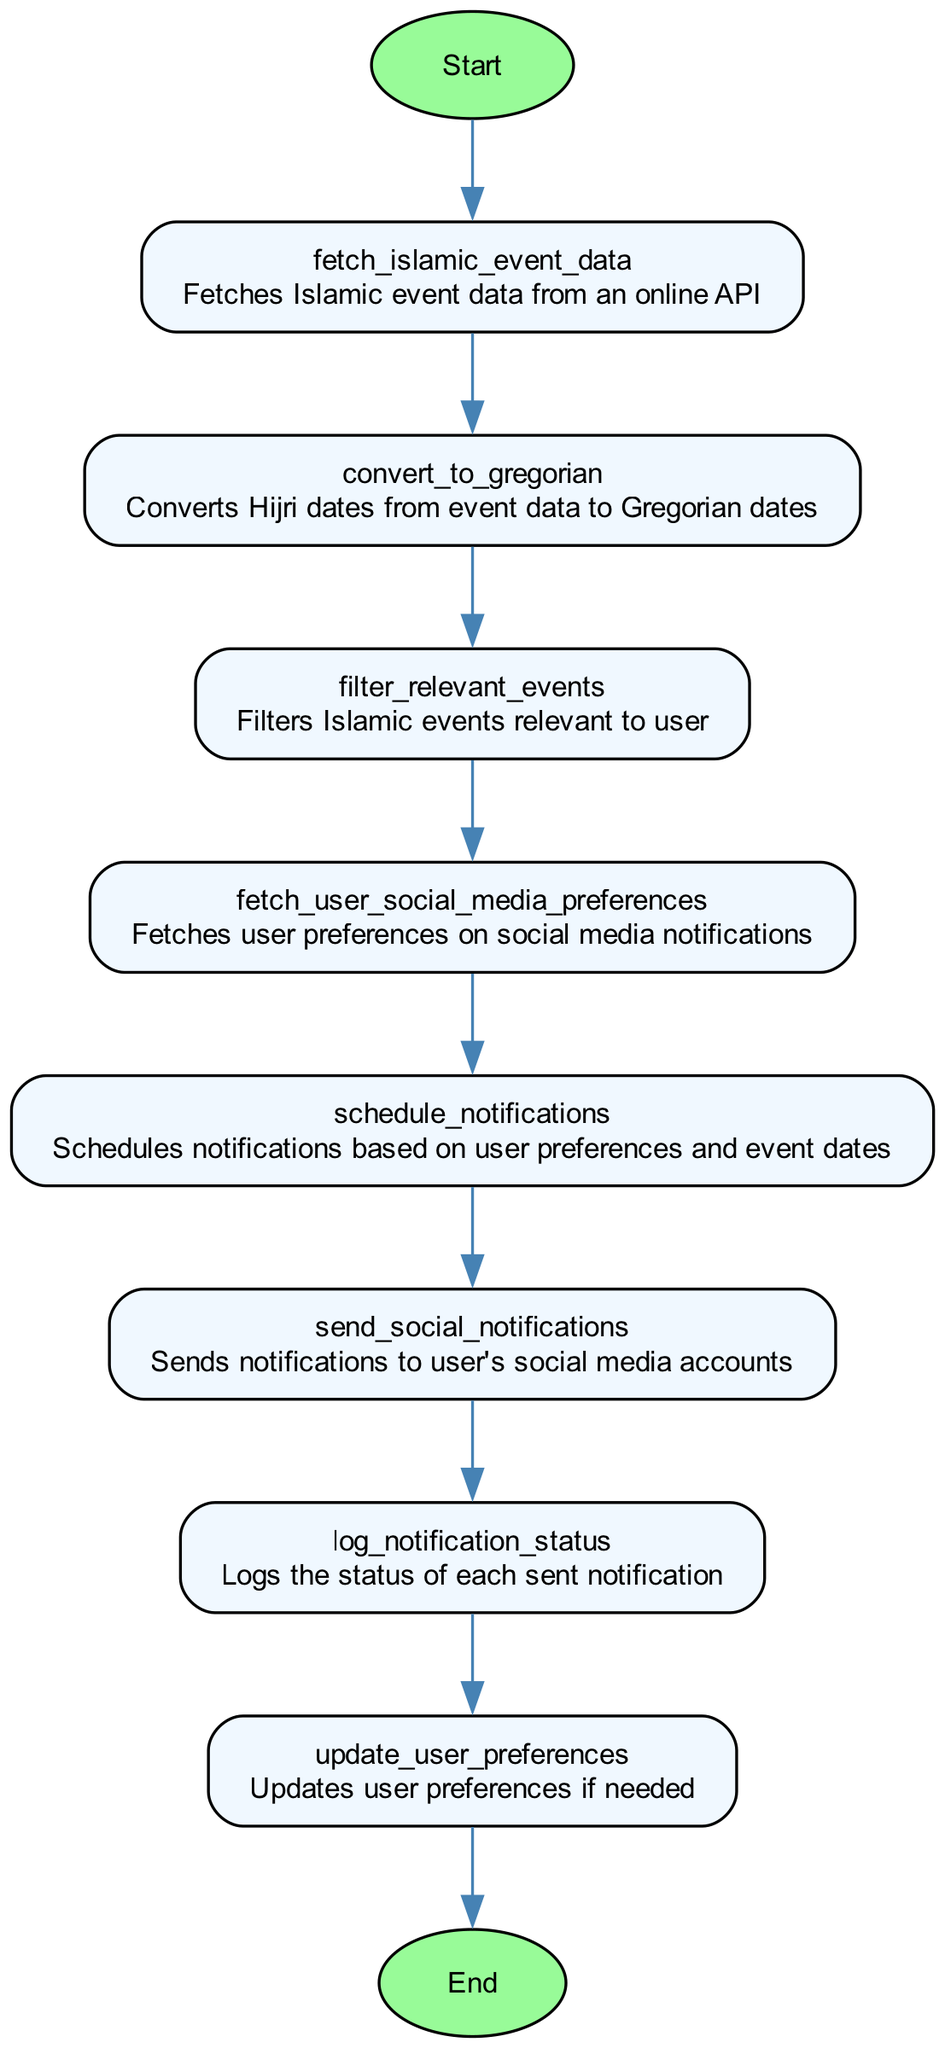What is the first function in the flowchart? The first node in the flowchart, which follows the start node and represents the initial step of the process, is "fetch_islamic_event_data".
Answer: fetch_islamic_event_data How many nodes are there in total in the diagram? By counting each unique function node and including the start and end nodes, we find that there are eight nodes in total.
Answer: eight What does the function "convert_to_gregorian" do? According to its description in the flowchart, "convert_to_gregorian" converts Hijri dates from event data to Gregorian dates.
Answer: Converts Hijri dates to Gregorian dates Which node follows "filter_relevant_events"? Following the "filter_relevant_events" node in the diagram, the next node is "fetch_user_social_media_preferences".
Answer: fetch_user_social_media_preferences What is the last action taken in the flowchart? The flowchart concludes with a node named "log_notification_status", which is directly followed by the end node, indicating the final action taken.
Answer: log_notification_status Which functions are responsible for notifications? The functions responsible for notifications based on user preferences and event dates are "schedule_notifications" and "send_social_notifications".
Answer: schedule_notifications and send_social_notifications What action occurs after logging the notification status? After the "log_notification_status" action is completed, the flowchart indicates that the process ends.
Answer: end What step comes immediately after fetching user preferences? Immediately after fetching user preferences, the next action is to "schedule_notifications" based on those preferences.
Answer: schedule_notifications 